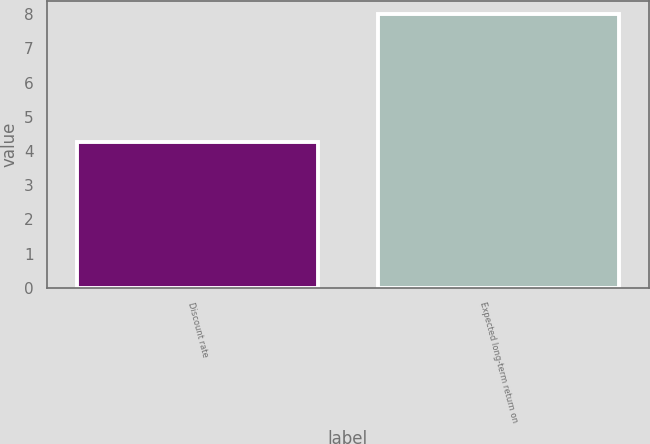<chart> <loc_0><loc_0><loc_500><loc_500><bar_chart><fcel>Discount rate<fcel>Expected long-term return on<nl><fcel>4.27<fcel>8<nl></chart> 